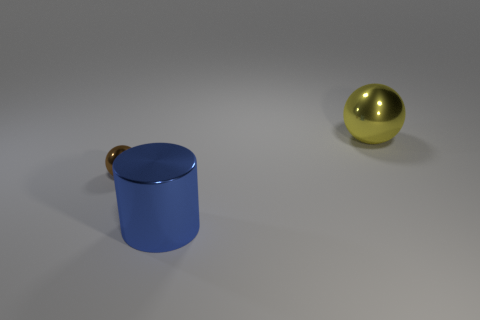Are the cylinder and the yellow object made of the same material?
Make the answer very short. Yes. There is a shiny sphere that is behind the thing that is on the left side of the cylinder; how many brown objects are in front of it?
Offer a terse response. 1. The metal thing that is behind the tiny brown ball has what shape?
Ensure brevity in your answer.  Sphere. Is the cylinder the same color as the large sphere?
Make the answer very short. No. Are there fewer large blue shiny things that are behind the brown metal thing than large yellow objects that are behind the big metal cylinder?
Provide a succinct answer. Yes. There is another object that is the same shape as the tiny brown object; what is its color?
Your answer should be very brief. Yellow. There is a metallic sphere right of the cylinder; is it the same size as the brown ball?
Your response must be concise. No. Are there fewer balls in front of the small object than small shiny balls?
Provide a succinct answer. Yes. Is there anything else that is the same size as the blue object?
Offer a terse response. Yes. There is a shiny sphere that is behind the metal thing that is to the left of the big blue shiny cylinder; what is its size?
Provide a succinct answer. Large. 